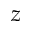Convert formula to latex. <formula><loc_0><loc_0><loc_500><loc_500>z</formula> 